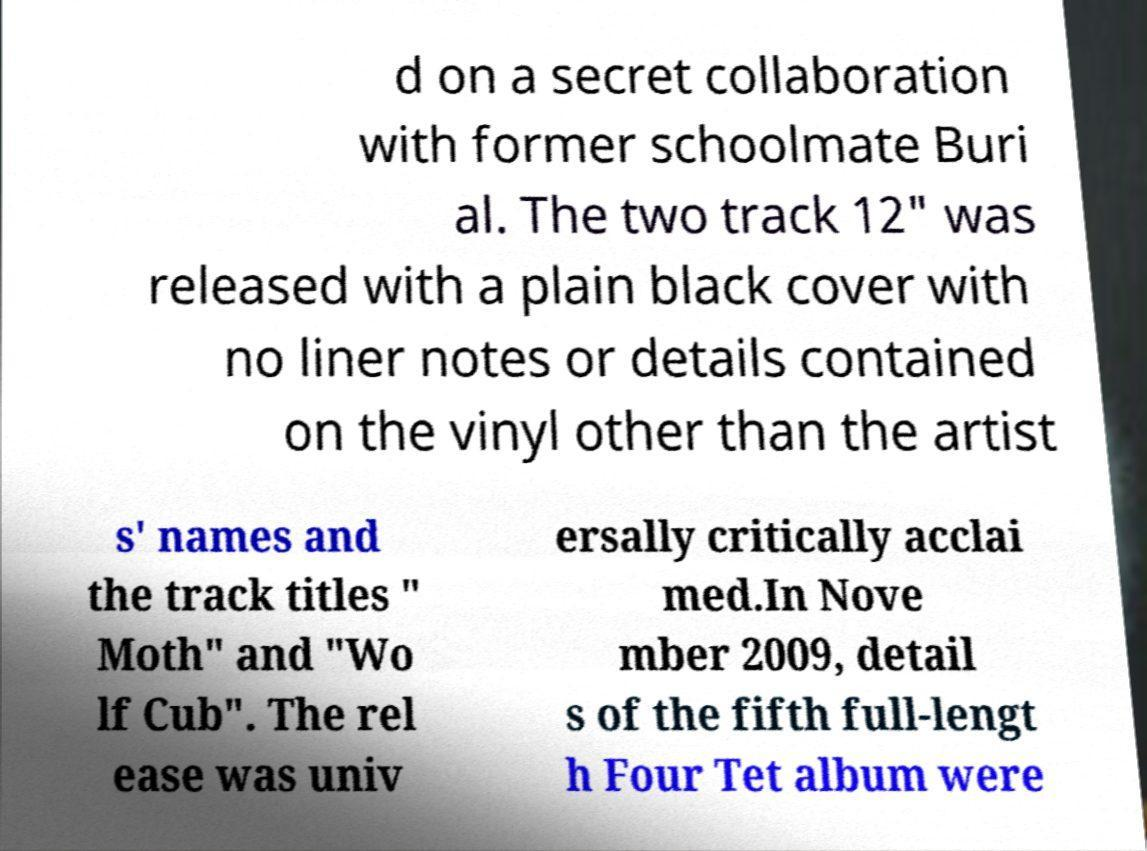Can you read and provide the text displayed in the image?This photo seems to have some interesting text. Can you extract and type it out for me? d on a secret collaboration with former schoolmate Buri al. The two track 12" was released with a plain black cover with no liner notes or details contained on the vinyl other than the artist s' names and the track titles " Moth" and "Wo lf Cub". The rel ease was univ ersally critically acclai med.In Nove mber 2009, detail s of the fifth full-lengt h Four Tet album were 